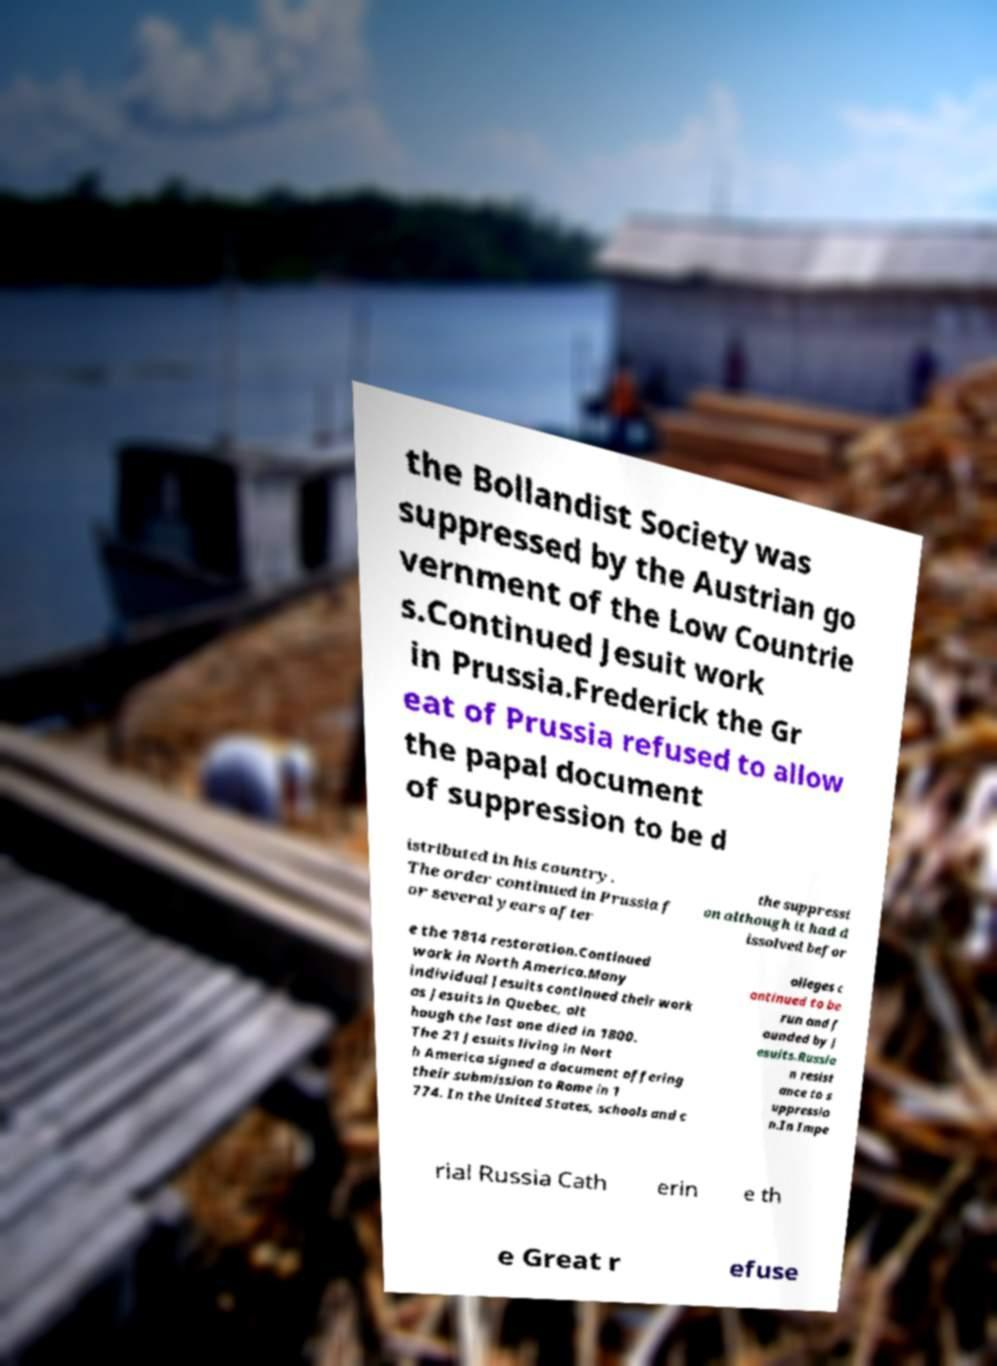Can you accurately transcribe the text from the provided image for me? the Bollandist Society was suppressed by the Austrian go vernment of the Low Countrie s.Continued Jesuit work in Prussia.Frederick the Gr eat of Prussia refused to allow the papal document of suppression to be d istributed in his country. The order continued in Prussia f or several years after the suppressi on although it had d issolved befor e the 1814 restoration.Continued work in North America.Many individual Jesuits continued their work as Jesuits in Quebec, alt hough the last one died in 1800. The 21 Jesuits living in Nort h America signed a document offering their submission to Rome in 1 774. In the United States, schools and c olleges c ontinued to be run and f ounded by J esuits.Russia n resist ance to s uppressio n.In Impe rial Russia Cath erin e th e Great r efuse 